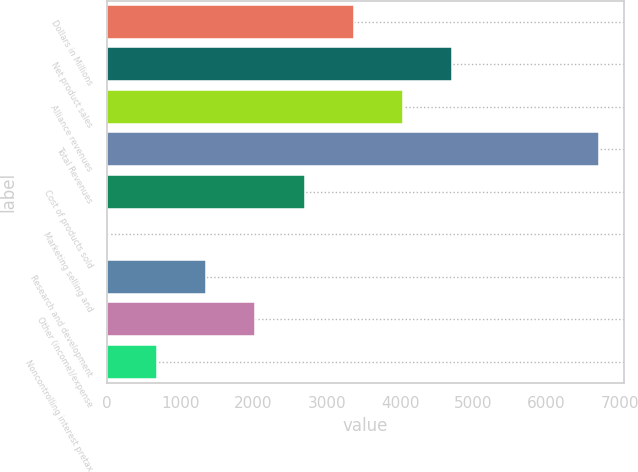Convert chart. <chart><loc_0><loc_0><loc_500><loc_500><bar_chart><fcel>Dollars in Millions<fcel>Net product sales<fcel>Alliance revenues<fcel>Total Revenues<fcel>Cost of products sold<fcel>Marketing selling and<fcel>Research and development<fcel>Other (income)/expense<fcel>Noncontrolling interest pretax<nl><fcel>3365.5<fcel>4705.7<fcel>4035.6<fcel>6716<fcel>2695.4<fcel>15<fcel>1355.2<fcel>2025.3<fcel>685.1<nl></chart> 